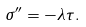<formula> <loc_0><loc_0><loc_500><loc_500>\sigma ^ { \prime \prime } = - \lambda \tau .</formula> 